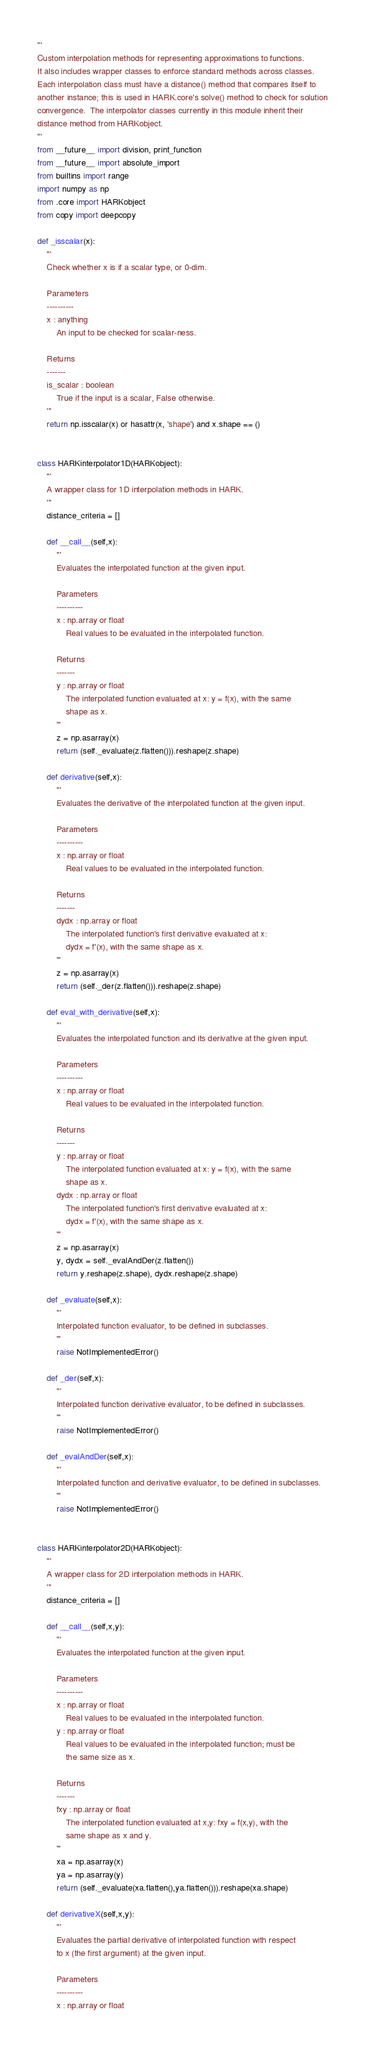<code> <loc_0><loc_0><loc_500><loc_500><_Python_>'''
Custom interpolation methods for representing approximations to functions.
It also includes wrapper classes to enforce standard methods across classes.
Each interpolation class must have a distance() method that compares itself to
another instance; this is used in HARK.core's solve() method to check for solution
convergence.  The interpolator classes currently in this module inherit their
distance method from HARKobject.
'''
from __future__ import division, print_function
from __future__ import absolute_import
from builtins import range
import numpy as np
from .core import HARKobject
from copy import deepcopy

def _isscalar(x):
    '''
    Check whether x is if a scalar type, or 0-dim.

    Parameters
    ----------
    x : anything
        An input to be checked for scalar-ness.

    Returns
    -------
    is_scalar : boolean
        True if the input is a scalar, False otherwise.
    '''
    return np.isscalar(x) or hasattr(x, 'shape') and x.shape == ()


class HARKinterpolator1D(HARKobject):
    '''
    A wrapper class for 1D interpolation methods in HARK.
    '''
    distance_criteria = []

    def __call__(self,x):
        '''
        Evaluates the interpolated function at the given input.

        Parameters
        ----------
        x : np.array or float
            Real values to be evaluated in the interpolated function.

        Returns
        -------
        y : np.array or float
            The interpolated function evaluated at x: y = f(x), with the same
            shape as x.
        '''
        z = np.asarray(x)
        return (self._evaluate(z.flatten())).reshape(z.shape)

    def derivative(self,x):
        '''
        Evaluates the derivative of the interpolated function at the given input.

        Parameters
        ----------
        x : np.array or float
            Real values to be evaluated in the interpolated function.

        Returns
        -------
        dydx : np.array or float
            The interpolated function's first derivative evaluated at x:
            dydx = f'(x), with the same shape as x.
        '''
        z = np.asarray(x)
        return (self._der(z.flatten())).reshape(z.shape)

    def eval_with_derivative(self,x):
        '''
        Evaluates the interpolated function and its derivative at the given input.

        Parameters
        ----------
        x : np.array or float
            Real values to be evaluated in the interpolated function.

        Returns
        -------
        y : np.array or float
            The interpolated function evaluated at x: y = f(x), with the same
            shape as x.
        dydx : np.array or float
            The interpolated function's first derivative evaluated at x:
            dydx = f'(x), with the same shape as x.
        '''
        z = np.asarray(x)
        y, dydx = self._evalAndDer(z.flatten())
        return y.reshape(z.shape), dydx.reshape(z.shape)

    def _evaluate(self,x):
        '''
        Interpolated function evaluator, to be defined in subclasses.
        '''
        raise NotImplementedError()

    def _der(self,x):
        '''
        Interpolated function derivative evaluator, to be defined in subclasses.
        '''
        raise NotImplementedError()

    def _evalAndDer(self,x):
        '''
        Interpolated function and derivative evaluator, to be defined in subclasses.
        '''
        raise NotImplementedError()


class HARKinterpolator2D(HARKobject):
    '''
    A wrapper class for 2D interpolation methods in HARK.
    '''
    distance_criteria = []

    def __call__(self,x,y):
        '''
        Evaluates the interpolated function at the given input.

        Parameters
        ----------
        x : np.array or float
            Real values to be evaluated in the interpolated function.
        y : np.array or float
            Real values to be evaluated in the interpolated function; must be
            the same size as x.

        Returns
        -------
        fxy : np.array or float
            The interpolated function evaluated at x,y: fxy = f(x,y), with the
            same shape as x and y.
        '''
        xa = np.asarray(x)
        ya = np.asarray(y)
        return (self._evaluate(xa.flatten(),ya.flatten())).reshape(xa.shape)

    def derivativeX(self,x,y):
        '''
        Evaluates the partial derivative of interpolated function with respect
        to x (the first argument) at the given input.

        Parameters
        ----------
        x : np.array or float</code> 